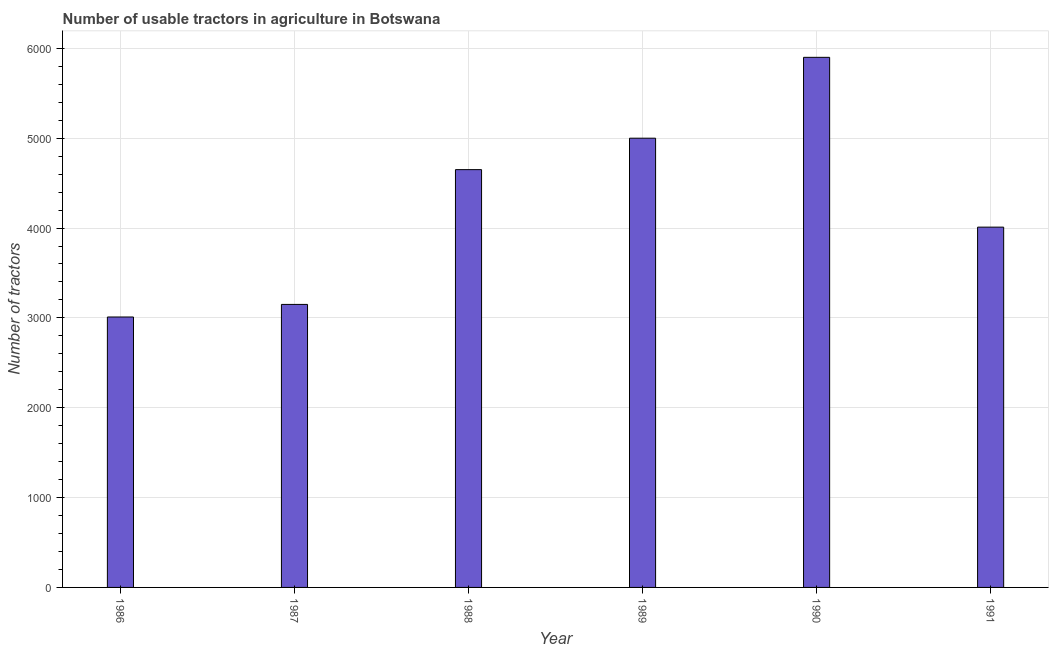What is the title of the graph?
Make the answer very short. Number of usable tractors in agriculture in Botswana. What is the label or title of the Y-axis?
Ensure brevity in your answer.  Number of tractors. What is the number of tractors in 1990?
Your answer should be very brief. 5900. Across all years, what is the maximum number of tractors?
Your answer should be very brief. 5900. Across all years, what is the minimum number of tractors?
Keep it short and to the point. 3010. In which year was the number of tractors maximum?
Your response must be concise. 1990. In which year was the number of tractors minimum?
Provide a short and direct response. 1986. What is the sum of the number of tractors?
Offer a very short reply. 2.57e+04. What is the difference between the number of tractors in 1987 and 1990?
Offer a very short reply. -2750. What is the average number of tractors per year?
Provide a short and direct response. 4286. What is the median number of tractors?
Provide a short and direct response. 4330. In how many years, is the number of tractors greater than 4200 ?
Make the answer very short. 3. What is the ratio of the number of tractors in 1988 to that in 1991?
Provide a short and direct response. 1.16. Is the number of tractors in 1986 less than that in 1989?
Ensure brevity in your answer.  Yes. What is the difference between the highest and the second highest number of tractors?
Offer a terse response. 900. What is the difference between the highest and the lowest number of tractors?
Your response must be concise. 2890. Are all the bars in the graph horizontal?
Your answer should be compact. No. What is the difference between two consecutive major ticks on the Y-axis?
Make the answer very short. 1000. What is the Number of tractors in 1986?
Provide a succinct answer. 3010. What is the Number of tractors in 1987?
Provide a short and direct response. 3150. What is the Number of tractors in 1988?
Offer a terse response. 4650. What is the Number of tractors of 1989?
Your answer should be very brief. 5000. What is the Number of tractors of 1990?
Provide a succinct answer. 5900. What is the Number of tractors in 1991?
Provide a succinct answer. 4010. What is the difference between the Number of tractors in 1986 and 1987?
Ensure brevity in your answer.  -140. What is the difference between the Number of tractors in 1986 and 1988?
Your answer should be very brief. -1640. What is the difference between the Number of tractors in 1986 and 1989?
Your answer should be compact. -1990. What is the difference between the Number of tractors in 1986 and 1990?
Make the answer very short. -2890. What is the difference between the Number of tractors in 1986 and 1991?
Your answer should be very brief. -1000. What is the difference between the Number of tractors in 1987 and 1988?
Provide a short and direct response. -1500. What is the difference between the Number of tractors in 1987 and 1989?
Offer a very short reply. -1850. What is the difference between the Number of tractors in 1987 and 1990?
Your response must be concise. -2750. What is the difference between the Number of tractors in 1987 and 1991?
Make the answer very short. -860. What is the difference between the Number of tractors in 1988 and 1989?
Provide a succinct answer. -350. What is the difference between the Number of tractors in 1988 and 1990?
Give a very brief answer. -1250. What is the difference between the Number of tractors in 1988 and 1991?
Give a very brief answer. 640. What is the difference between the Number of tractors in 1989 and 1990?
Your answer should be compact. -900. What is the difference between the Number of tractors in 1989 and 1991?
Make the answer very short. 990. What is the difference between the Number of tractors in 1990 and 1991?
Give a very brief answer. 1890. What is the ratio of the Number of tractors in 1986 to that in 1987?
Provide a succinct answer. 0.96. What is the ratio of the Number of tractors in 1986 to that in 1988?
Provide a short and direct response. 0.65. What is the ratio of the Number of tractors in 1986 to that in 1989?
Make the answer very short. 0.6. What is the ratio of the Number of tractors in 1986 to that in 1990?
Provide a succinct answer. 0.51. What is the ratio of the Number of tractors in 1986 to that in 1991?
Your response must be concise. 0.75. What is the ratio of the Number of tractors in 1987 to that in 1988?
Your answer should be very brief. 0.68. What is the ratio of the Number of tractors in 1987 to that in 1989?
Keep it short and to the point. 0.63. What is the ratio of the Number of tractors in 1987 to that in 1990?
Provide a short and direct response. 0.53. What is the ratio of the Number of tractors in 1987 to that in 1991?
Give a very brief answer. 0.79. What is the ratio of the Number of tractors in 1988 to that in 1989?
Your response must be concise. 0.93. What is the ratio of the Number of tractors in 1988 to that in 1990?
Ensure brevity in your answer.  0.79. What is the ratio of the Number of tractors in 1988 to that in 1991?
Your answer should be compact. 1.16. What is the ratio of the Number of tractors in 1989 to that in 1990?
Your response must be concise. 0.85. What is the ratio of the Number of tractors in 1989 to that in 1991?
Your response must be concise. 1.25. What is the ratio of the Number of tractors in 1990 to that in 1991?
Your answer should be very brief. 1.47. 